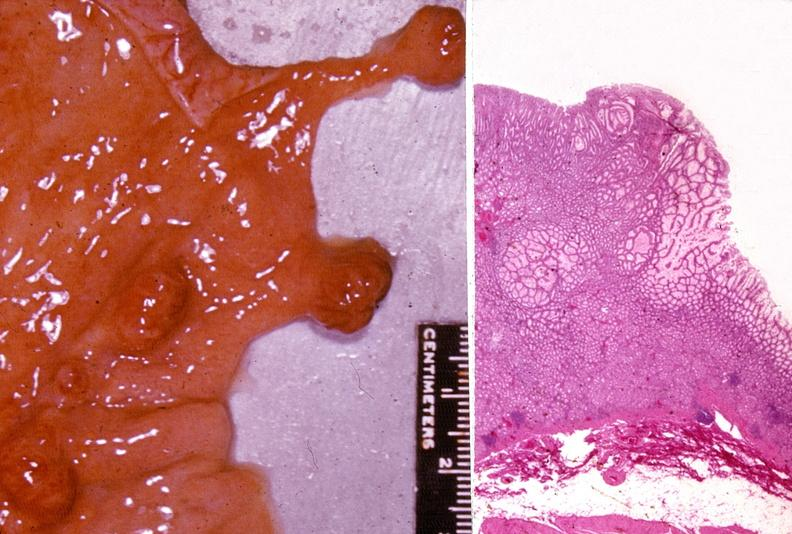what is present?
Answer the question using a single word or phrase. Gastrointestinal 